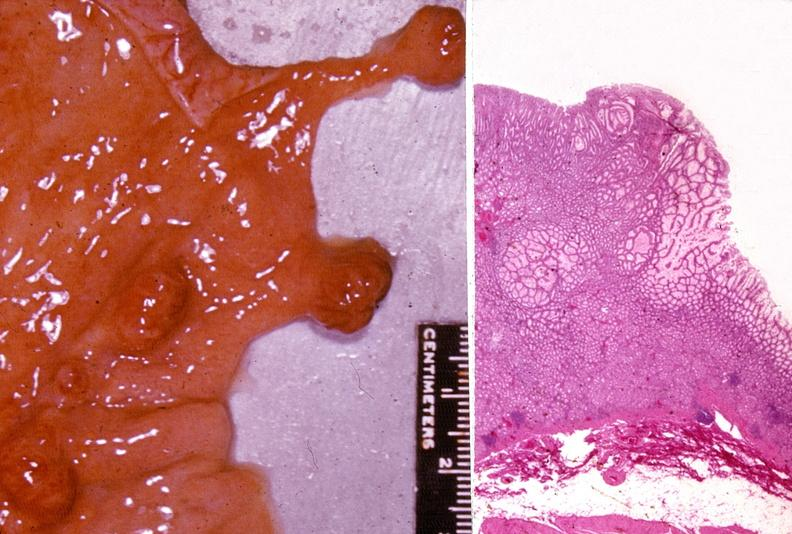what is present?
Answer the question using a single word or phrase. Gastrointestinal 